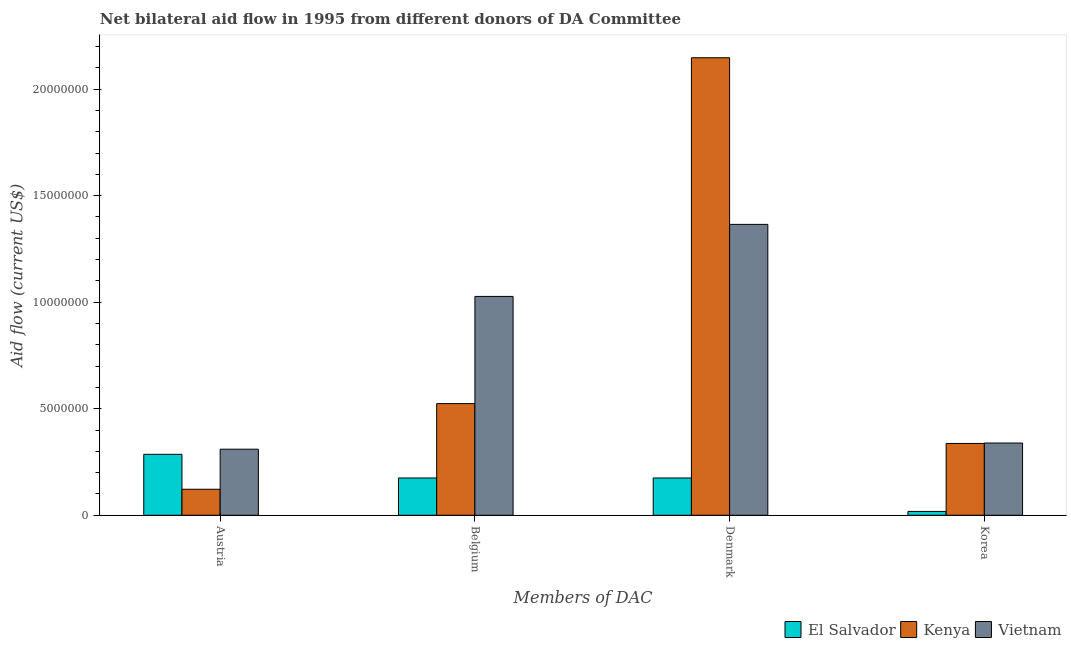How many different coloured bars are there?
Provide a succinct answer. 3. Are the number of bars per tick equal to the number of legend labels?
Provide a short and direct response. Yes. Are the number of bars on each tick of the X-axis equal?
Give a very brief answer. Yes. How many bars are there on the 4th tick from the left?
Your answer should be compact. 3. What is the label of the 1st group of bars from the left?
Offer a very short reply. Austria. What is the amount of aid given by denmark in Kenya?
Keep it short and to the point. 2.15e+07. Across all countries, what is the maximum amount of aid given by austria?
Give a very brief answer. 3.10e+06. Across all countries, what is the minimum amount of aid given by austria?
Offer a terse response. 1.22e+06. In which country was the amount of aid given by belgium maximum?
Your response must be concise. Vietnam. In which country was the amount of aid given by belgium minimum?
Provide a succinct answer. El Salvador. What is the total amount of aid given by austria in the graph?
Make the answer very short. 7.18e+06. What is the difference between the amount of aid given by denmark in Vietnam and that in Kenya?
Make the answer very short. -7.82e+06. What is the difference between the amount of aid given by denmark in Vietnam and the amount of aid given by belgium in Kenya?
Offer a terse response. 8.41e+06. What is the average amount of aid given by denmark per country?
Your response must be concise. 1.23e+07. What is the difference between the amount of aid given by austria and amount of aid given by belgium in Kenya?
Provide a short and direct response. -4.02e+06. In how many countries, is the amount of aid given by austria greater than 16000000 US$?
Provide a short and direct response. 0. What is the ratio of the amount of aid given by belgium in Vietnam to that in El Salvador?
Offer a very short reply. 5.87. Is the difference between the amount of aid given by austria in El Salvador and Vietnam greater than the difference between the amount of aid given by denmark in El Salvador and Vietnam?
Provide a short and direct response. Yes. What is the difference between the highest and the second highest amount of aid given by denmark?
Offer a very short reply. 7.82e+06. What is the difference between the highest and the lowest amount of aid given by belgium?
Offer a terse response. 8.52e+06. In how many countries, is the amount of aid given by austria greater than the average amount of aid given by austria taken over all countries?
Give a very brief answer. 2. What does the 3rd bar from the left in Korea represents?
Give a very brief answer. Vietnam. What does the 3rd bar from the right in Belgium represents?
Give a very brief answer. El Salvador. Is it the case that in every country, the sum of the amount of aid given by austria and amount of aid given by belgium is greater than the amount of aid given by denmark?
Ensure brevity in your answer.  No. How many countries are there in the graph?
Provide a short and direct response. 3. Are the values on the major ticks of Y-axis written in scientific E-notation?
Your response must be concise. No. Does the graph contain any zero values?
Ensure brevity in your answer.  No. Does the graph contain grids?
Ensure brevity in your answer.  No. Where does the legend appear in the graph?
Your answer should be compact. Bottom right. How many legend labels are there?
Provide a succinct answer. 3. What is the title of the graph?
Provide a succinct answer. Net bilateral aid flow in 1995 from different donors of DA Committee. Does "Barbados" appear as one of the legend labels in the graph?
Your answer should be compact. No. What is the label or title of the X-axis?
Your answer should be compact. Members of DAC. What is the Aid flow (current US$) in El Salvador in Austria?
Make the answer very short. 2.86e+06. What is the Aid flow (current US$) of Kenya in Austria?
Make the answer very short. 1.22e+06. What is the Aid flow (current US$) in Vietnam in Austria?
Your answer should be very brief. 3.10e+06. What is the Aid flow (current US$) in El Salvador in Belgium?
Provide a succinct answer. 1.75e+06. What is the Aid flow (current US$) in Kenya in Belgium?
Give a very brief answer. 5.24e+06. What is the Aid flow (current US$) in Vietnam in Belgium?
Offer a very short reply. 1.03e+07. What is the Aid flow (current US$) of El Salvador in Denmark?
Provide a succinct answer. 1.75e+06. What is the Aid flow (current US$) in Kenya in Denmark?
Your answer should be compact. 2.15e+07. What is the Aid flow (current US$) of Vietnam in Denmark?
Your answer should be compact. 1.36e+07. What is the Aid flow (current US$) of El Salvador in Korea?
Keep it short and to the point. 1.80e+05. What is the Aid flow (current US$) in Kenya in Korea?
Your response must be concise. 3.37e+06. What is the Aid flow (current US$) in Vietnam in Korea?
Keep it short and to the point. 3.39e+06. Across all Members of DAC, what is the maximum Aid flow (current US$) in El Salvador?
Give a very brief answer. 2.86e+06. Across all Members of DAC, what is the maximum Aid flow (current US$) of Kenya?
Make the answer very short. 2.15e+07. Across all Members of DAC, what is the maximum Aid flow (current US$) of Vietnam?
Offer a terse response. 1.36e+07. Across all Members of DAC, what is the minimum Aid flow (current US$) of El Salvador?
Offer a very short reply. 1.80e+05. Across all Members of DAC, what is the minimum Aid flow (current US$) of Kenya?
Keep it short and to the point. 1.22e+06. Across all Members of DAC, what is the minimum Aid flow (current US$) in Vietnam?
Offer a very short reply. 3.10e+06. What is the total Aid flow (current US$) of El Salvador in the graph?
Ensure brevity in your answer.  6.54e+06. What is the total Aid flow (current US$) in Kenya in the graph?
Make the answer very short. 3.13e+07. What is the total Aid flow (current US$) in Vietnam in the graph?
Keep it short and to the point. 3.04e+07. What is the difference between the Aid flow (current US$) in El Salvador in Austria and that in Belgium?
Your answer should be compact. 1.11e+06. What is the difference between the Aid flow (current US$) of Kenya in Austria and that in Belgium?
Provide a succinct answer. -4.02e+06. What is the difference between the Aid flow (current US$) of Vietnam in Austria and that in Belgium?
Give a very brief answer. -7.17e+06. What is the difference between the Aid flow (current US$) in El Salvador in Austria and that in Denmark?
Keep it short and to the point. 1.11e+06. What is the difference between the Aid flow (current US$) of Kenya in Austria and that in Denmark?
Offer a very short reply. -2.02e+07. What is the difference between the Aid flow (current US$) in Vietnam in Austria and that in Denmark?
Your response must be concise. -1.06e+07. What is the difference between the Aid flow (current US$) in El Salvador in Austria and that in Korea?
Your response must be concise. 2.68e+06. What is the difference between the Aid flow (current US$) in Kenya in Austria and that in Korea?
Provide a succinct answer. -2.15e+06. What is the difference between the Aid flow (current US$) in Vietnam in Austria and that in Korea?
Provide a short and direct response. -2.90e+05. What is the difference between the Aid flow (current US$) in El Salvador in Belgium and that in Denmark?
Your response must be concise. 0. What is the difference between the Aid flow (current US$) in Kenya in Belgium and that in Denmark?
Ensure brevity in your answer.  -1.62e+07. What is the difference between the Aid flow (current US$) in Vietnam in Belgium and that in Denmark?
Your answer should be very brief. -3.38e+06. What is the difference between the Aid flow (current US$) in El Salvador in Belgium and that in Korea?
Your answer should be compact. 1.57e+06. What is the difference between the Aid flow (current US$) in Kenya in Belgium and that in Korea?
Give a very brief answer. 1.87e+06. What is the difference between the Aid flow (current US$) of Vietnam in Belgium and that in Korea?
Your answer should be very brief. 6.88e+06. What is the difference between the Aid flow (current US$) of El Salvador in Denmark and that in Korea?
Make the answer very short. 1.57e+06. What is the difference between the Aid flow (current US$) in Kenya in Denmark and that in Korea?
Provide a short and direct response. 1.81e+07. What is the difference between the Aid flow (current US$) of Vietnam in Denmark and that in Korea?
Make the answer very short. 1.03e+07. What is the difference between the Aid flow (current US$) of El Salvador in Austria and the Aid flow (current US$) of Kenya in Belgium?
Your answer should be compact. -2.38e+06. What is the difference between the Aid flow (current US$) in El Salvador in Austria and the Aid flow (current US$) in Vietnam in Belgium?
Give a very brief answer. -7.41e+06. What is the difference between the Aid flow (current US$) in Kenya in Austria and the Aid flow (current US$) in Vietnam in Belgium?
Provide a short and direct response. -9.05e+06. What is the difference between the Aid flow (current US$) in El Salvador in Austria and the Aid flow (current US$) in Kenya in Denmark?
Offer a terse response. -1.86e+07. What is the difference between the Aid flow (current US$) in El Salvador in Austria and the Aid flow (current US$) in Vietnam in Denmark?
Provide a succinct answer. -1.08e+07. What is the difference between the Aid flow (current US$) of Kenya in Austria and the Aid flow (current US$) of Vietnam in Denmark?
Ensure brevity in your answer.  -1.24e+07. What is the difference between the Aid flow (current US$) of El Salvador in Austria and the Aid flow (current US$) of Kenya in Korea?
Offer a terse response. -5.10e+05. What is the difference between the Aid flow (current US$) of El Salvador in Austria and the Aid flow (current US$) of Vietnam in Korea?
Provide a short and direct response. -5.30e+05. What is the difference between the Aid flow (current US$) in Kenya in Austria and the Aid flow (current US$) in Vietnam in Korea?
Ensure brevity in your answer.  -2.17e+06. What is the difference between the Aid flow (current US$) in El Salvador in Belgium and the Aid flow (current US$) in Kenya in Denmark?
Ensure brevity in your answer.  -1.97e+07. What is the difference between the Aid flow (current US$) in El Salvador in Belgium and the Aid flow (current US$) in Vietnam in Denmark?
Your answer should be compact. -1.19e+07. What is the difference between the Aid flow (current US$) in Kenya in Belgium and the Aid flow (current US$) in Vietnam in Denmark?
Keep it short and to the point. -8.41e+06. What is the difference between the Aid flow (current US$) in El Salvador in Belgium and the Aid flow (current US$) in Kenya in Korea?
Ensure brevity in your answer.  -1.62e+06. What is the difference between the Aid flow (current US$) of El Salvador in Belgium and the Aid flow (current US$) of Vietnam in Korea?
Keep it short and to the point. -1.64e+06. What is the difference between the Aid flow (current US$) in Kenya in Belgium and the Aid flow (current US$) in Vietnam in Korea?
Your answer should be very brief. 1.85e+06. What is the difference between the Aid flow (current US$) of El Salvador in Denmark and the Aid flow (current US$) of Kenya in Korea?
Keep it short and to the point. -1.62e+06. What is the difference between the Aid flow (current US$) of El Salvador in Denmark and the Aid flow (current US$) of Vietnam in Korea?
Give a very brief answer. -1.64e+06. What is the difference between the Aid flow (current US$) in Kenya in Denmark and the Aid flow (current US$) in Vietnam in Korea?
Keep it short and to the point. 1.81e+07. What is the average Aid flow (current US$) in El Salvador per Members of DAC?
Keep it short and to the point. 1.64e+06. What is the average Aid flow (current US$) of Kenya per Members of DAC?
Make the answer very short. 7.82e+06. What is the average Aid flow (current US$) in Vietnam per Members of DAC?
Offer a terse response. 7.60e+06. What is the difference between the Aid flow (current US$) of El Salvador and Aid flow (current US$) of Kenya in Austria?
Give a very brief answer. 1.64e+06. What is the difference between the Aid flow (current US$) of El Salvador and Aid flow (current US$) of Vietnam in Austria?
Make the answer very short. -2.40e+05. What is the difference between the Aid flow (current US$) of Kenya and Aid flow (current US$) of Vietnam in Austria?
Provide a short and direct response. -1.88e+06. What is the difference between the Aid flow (current US$) in El Salvador and Aid flow (current US$) in Kenya in Belgium?
Offer a terse response. -3.49e+06. What is the difference between the Aid flow (current US$) of El Salvador and Aid flow (current US$) of Vietnam in Belgium?
Provide a short and direct response. -8.52e+06. What is the difference between the Aid flow (current US$) of Kenya and Aid flow (current US$) of Vietnam in Belgium?
Your response must be concise. -5.03e+06. What is the difference between the Aid flow (current US$) of El Salvador and Aid flow (current US$) of Kenya in Denmark?
Keep it short and to the point. -1.97e+07. What is the difference between the Aid flow (current US$) of El Salvador and Aid flow (current US$) of Vietnam in Denmark?
Your answer should be compact. -1.19e+07. What is the difference between the Aid flow (current US$) of Kenya and Aid flow (current US$) of Vietnam in Denmark?
Ensure brevity in your answer.  7.82e+06. What is the difference between the Aid flow (current US$) of El Salvador and Aid flow (current US$) of Kenya in Korea?
Offer a terse response. -3.19e+06. What is the difference between the Aid flow (current US$) in El Salvador and Aid flow (current US$) in Vietnam in Korea?
Give a very brief answer. -3.21e+06. What is the difference between the Aid flow (current US$) of Kenya and Aid flow (current US$) of Vietnam in Korea?
Make the answer very short. -2.00e+04. What is the ratio of the Aid flow (current US$) in El Salvador in Austria to that in Belgium?
Make the answer very short. 1.63. What is the ratio of the Aid flow (current US$) in Kenya in Austria to that in Belgium?
Ensure brevity in your answer.  0.23. What is the ratio of the Aid flow (current US$) of Vietnam in Austria to that in Belgium?
Your response must be concise. 0.3. What is the ratio of the Aid flow (current US$) in El Salvador in Austria to that in Denmark?
Give a very brief answer. 1.63. What is the ratio of the Aid flow (current US$) in Kenya in Austria to that in Denmark?
Offer a very short reply. 0.06. What is the ratio of the Aid flow (current US$) in Vietnam in Austria to that in Denmark?
Offer a very short reply. 0.23. What is the ratio of the Aid flow (current US$) in El Salvador in Austria to that in Korea?
Offer a very short reply. 15.89. What is the ratio of the Aid flow (current US$) in Kenya in Austria to that in Korea?
Provide a short and direct response. 0.36. What is the ratio of the Aid flow (current US$) of Vietnam in Austria to that in Korea?
Ensure brevity in your answer.  0.91. What is the ratio of the Aid flow (current US$) in Kenya in Belgium to that in Denmark?
Make the answer very short. 0.24. What is the ratio of the Aid flow (current US$) in Vietnam in Belgium to that in Denmark?
Offer a very short reply. 0.75. What is the ratio of the Aid flow (current US$) in El Salvador in Belgium to that in Korea?
Your response must be concise. 9.72. What is the ratio of the Aid flow (current US$) in Kenya in Belgium to that in Korea?
Provide a short and direct response. 1.55. What is the ratio of the Aid flow (current US$) of Vietnam in Belgium to that in Korea?
Provide a short and direct response. 3.03. What is the ratio of the Aid flow (current US$) in El Salvador in Denmark to that in Korea?
Offer a very short reply. 9.72. What is the ratio of the Aid flow (current US$) of Kenya in Denmark to that in Korea?
Your response must be concise. 6.37. What is the ratio of the Aid flow (current US$) in Vietnam in Denmark to that in Korea?
Provide a succinct answer. 4.03. What is the difference between the highest and the second highest Aid flow (current US$) of El Salvador?
Keep it short and to the point. 1.11e+06. What is the difference between the highest and the second highest Aid flow (current US$) in Kenya?
Your response must be concise. 1.62e+07. What is the difference between the highest and the second highest Aid flow (current US$) in Vietnam?
Provide a succinct answer. 3.38e+06. What is the difference between the highest and the lowest Aid flow (current US$) of El Salvador?
Make the answer very short. 2.68e+06. What is the difference between the highest and the lowest Aid flow (current US$) in Kenya?
Offer a terse response. 2.02e+07. What is the difference between the highest and the lowest Aid flow (current US$) in Vietnam?
Your answer should be very brief. 1.06e+07. 